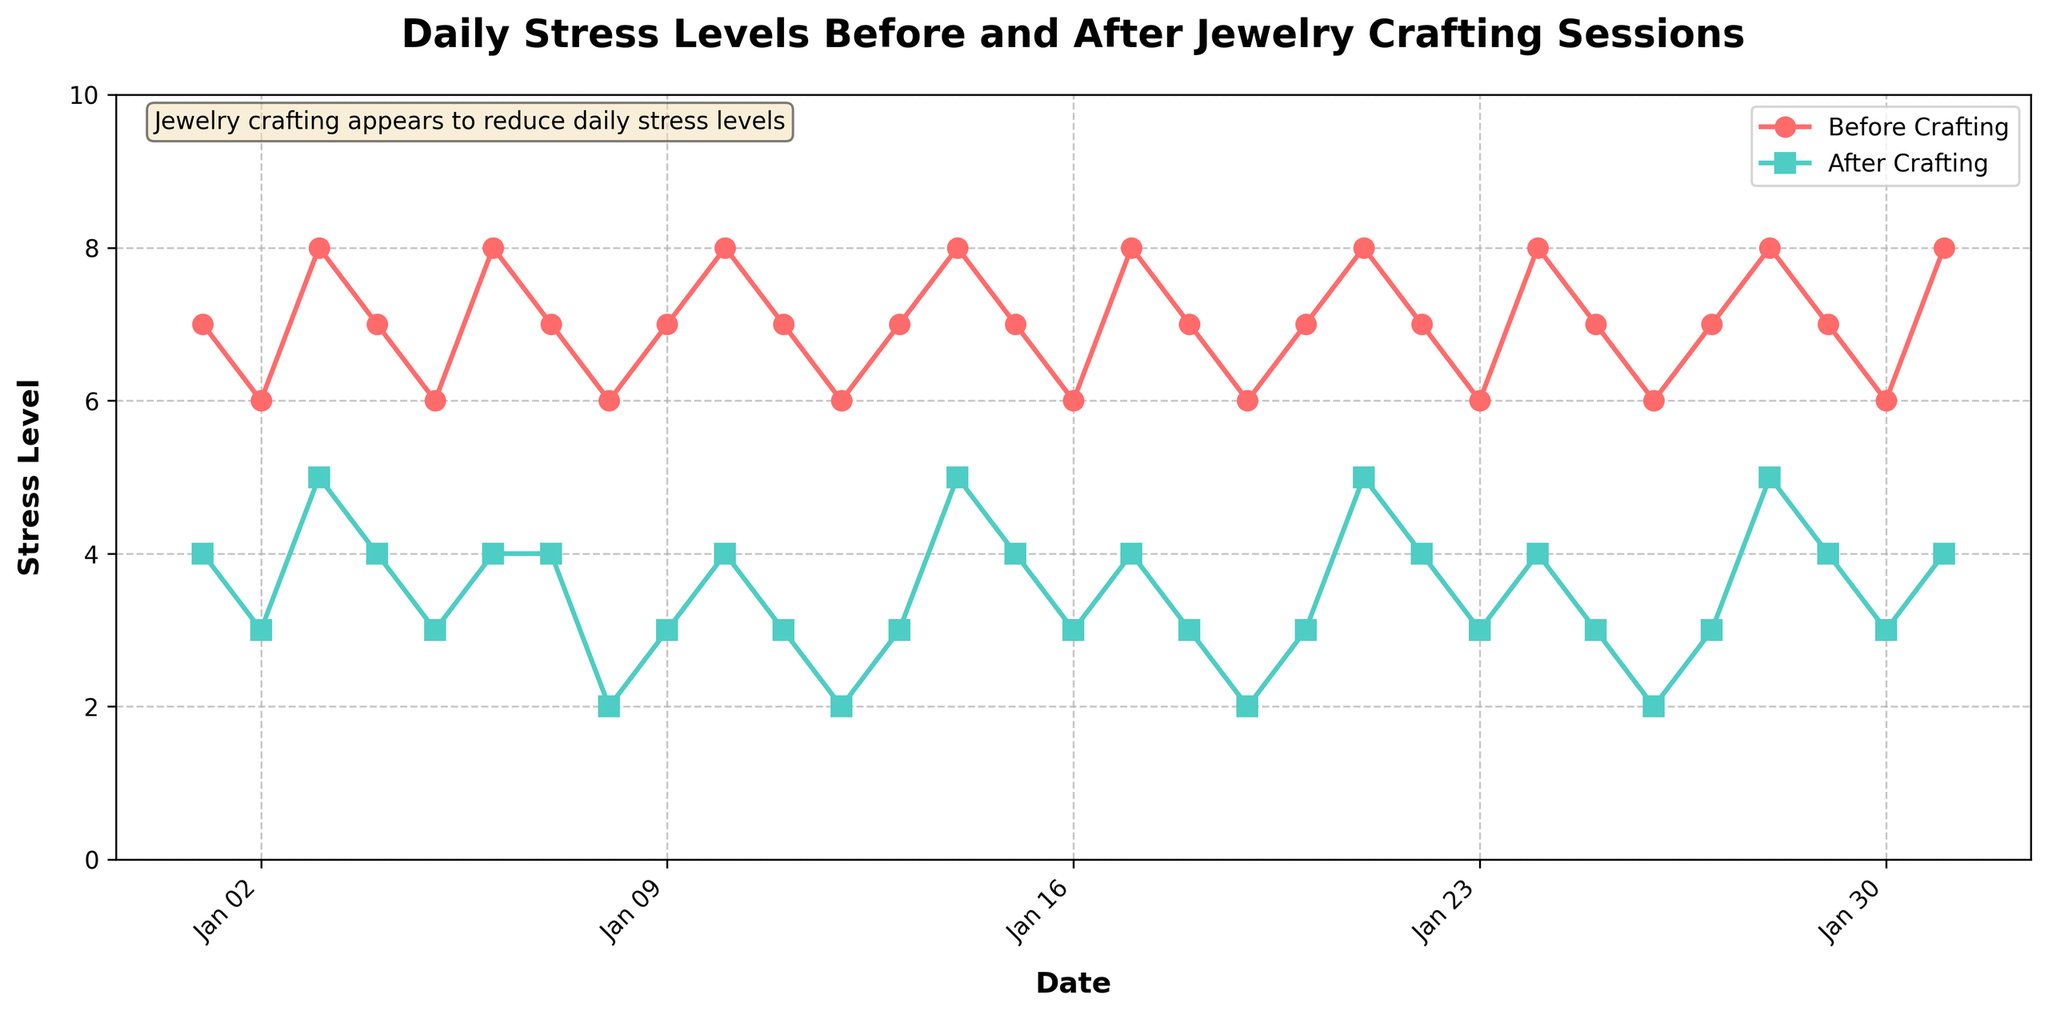How many days are plotted in the graph? Count the number of data points along the x-axis, each representing a day. There are 31 days plotted.
Answer: 31 What are the colors used for the 'Before Crafting' and 'After Crafting' lines? The 'Before Crafting' line is colored red, and the 'After Crafting' line is colored teal.
Answer: Red and teal What is the highest stress level recorded before participating in jewelry crafting sessions? Look for the highest point on the 'Before Crafting' line. The highest value is 8.
Answer: 8 What is the average stress level after participating in jewelry crafting sessions? Sum all stress levels in the 'After Crafting' column and divide by the number of days (31). The sum is 107, so the average is 107/31 ≈ 3.45.
Answer: 3.45 On which date is the stress reduction (difference between Before and After) the greatest? Calculate the difference for each day (Stress_Level_Before - Stress_Level_After) and identify the maximum. The maximum difference is 4, occurring on January 8, January 12, January 19, and January 26.
Answer: January 8, January 12, January 19, January 26 On which date were the stress levels before and after crafting sessions equal? Compare Stress_Level_Before and Stress_Level_After for each day. No date has equal stress levels before and after.
Answer: None How does the trend in daily stress levels before crafting compare to after crafting? Observe the general movement of both lines. The 'Before Crafting' line remains consistently higher, while the 'After Crafting' line shows a decrease and stays lower.
Answer: 'Before Crafting' higher, 'After Crafting' lower What was the stress level before crafting on January 15th, and how did it change after crafting? Look at the stress levels for January 15th. It was 7 before crafting and decreased to 4 after crafting.
Answer: 7 (before), 4 (after) Is there a pattern in the days when the stress level before crafting was at its peak? Identify the days with peak Stress_Level_Before (8). The peaks occur on January 3, January 6, January 10, January 14, January 17, January 21, January 24, January 28, and January 31, showing a repeating interval of 3-4 days.
Answer: Every 3-4 days What can be inferred about the effectiveness of jewelry crafting sessions in reducing daily stress levels? The 'After Crafting' stress levels are consistently lower than 'Before Crafting' levels, indicating that the sessions effectively reduce stress.
Answer: Effective 